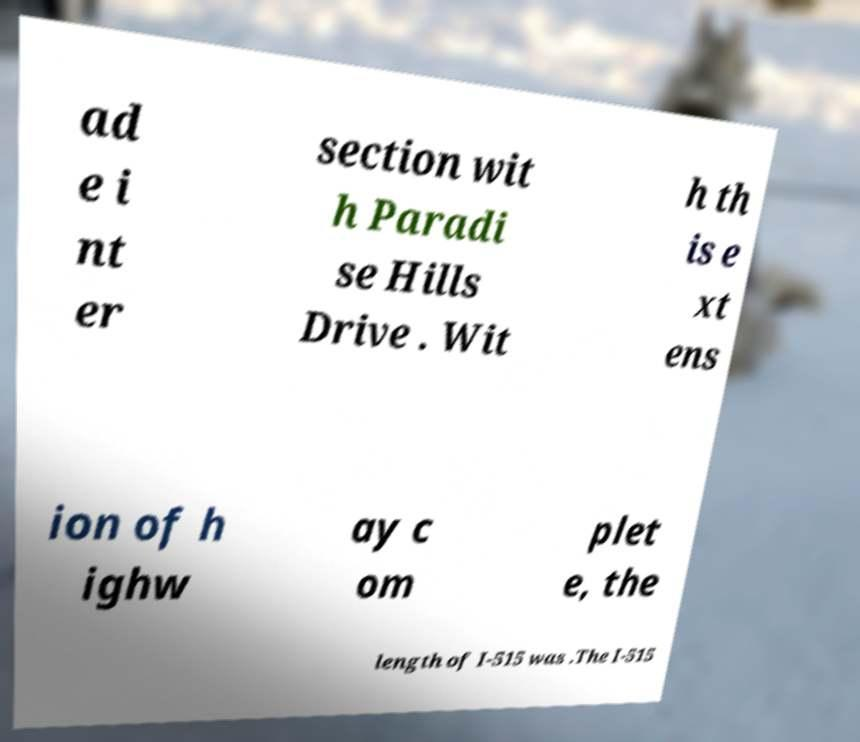I need the written content from this picture converted into text. Can you do that? ad e i nt er section wit h Paradi se Hills Drive . Wit h th is e xt ens ion of h ighw ay c om plet e, the length of I-515 was .The I-515 